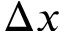Convert formula to latex. <formula><loc_0><loc_0><loc_500><loc_500>\Delta x</formula> 